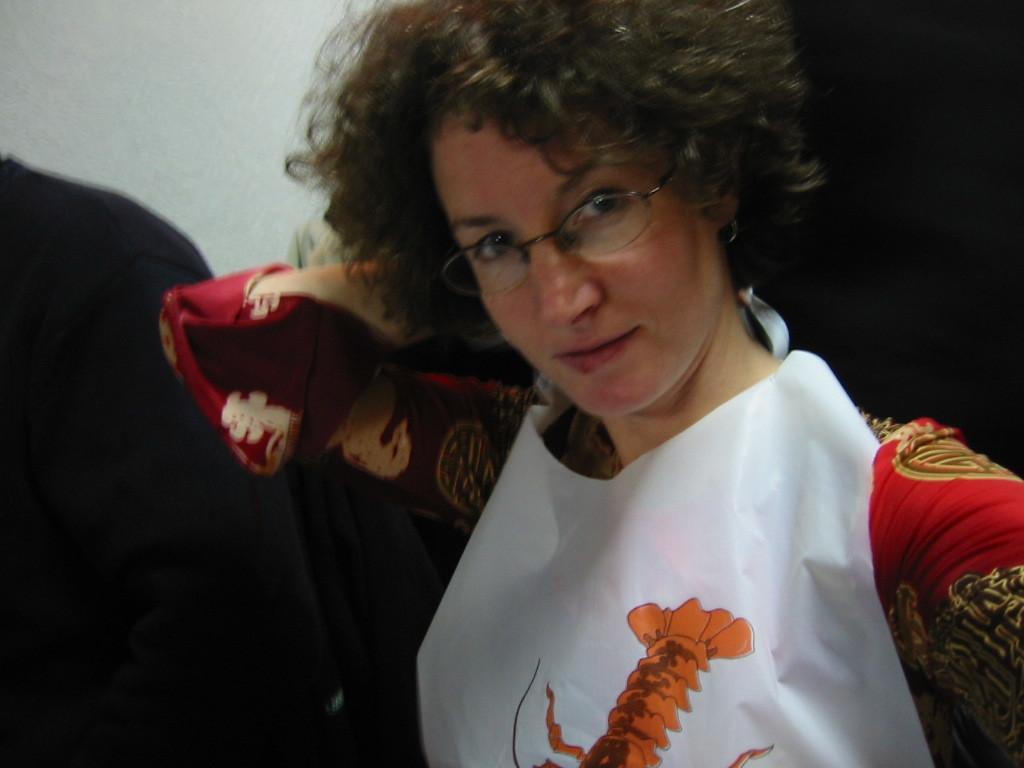In one or two sentences, can you explain what this image depicts? This image consist of a woman wearing red dress and white apron. In the background, there is a white wall. She is wearing spectacles. 